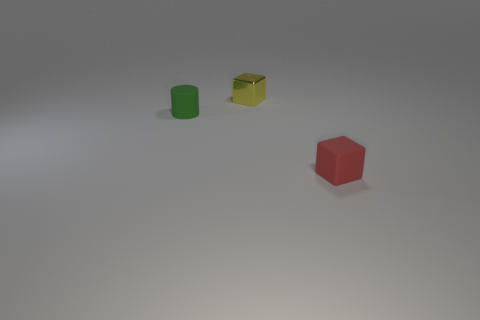Add 2 tiny blue rubber spheres. How many objects exist? 5 Subtract all yellow cubes. How many cubes are left? 1 Subtract 1 blocks. How many blocks are left? 1 Subtract 0 blue balls. How many objects are left? 3 Subtract all cylinders. How many objects are left? 2 Subtract all purple cylinders. Subtract all red blocks. How many cylinders are left? 1 Subtract all gray blocks. How many blue cylinders are left? 0 Subtract all purple things. Subtract all yellow shiny objects. How many objects are left? 2 Add 1 tiny yellow objects. How many tiny yellow objects are left? 2 Add 1 small rubber blocks. How many small rubber blocks exist? 2 